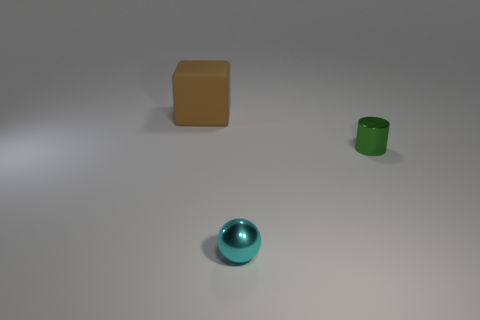Add 3 small brown cylinders. How many objects exist? 6 Subtract all cylinders. How many objects are left? 2 Subtract 0 purple cubes. How many objects are left? 3 Subtract all small green shiny cylinders. Subtract all small green cylinders. How many objects are left? 1 Add 3 cyan metal spheres. How many cyan metal spheres are left? 4 Add 1 purple rubber things. How many purple rubber things exist? 1 